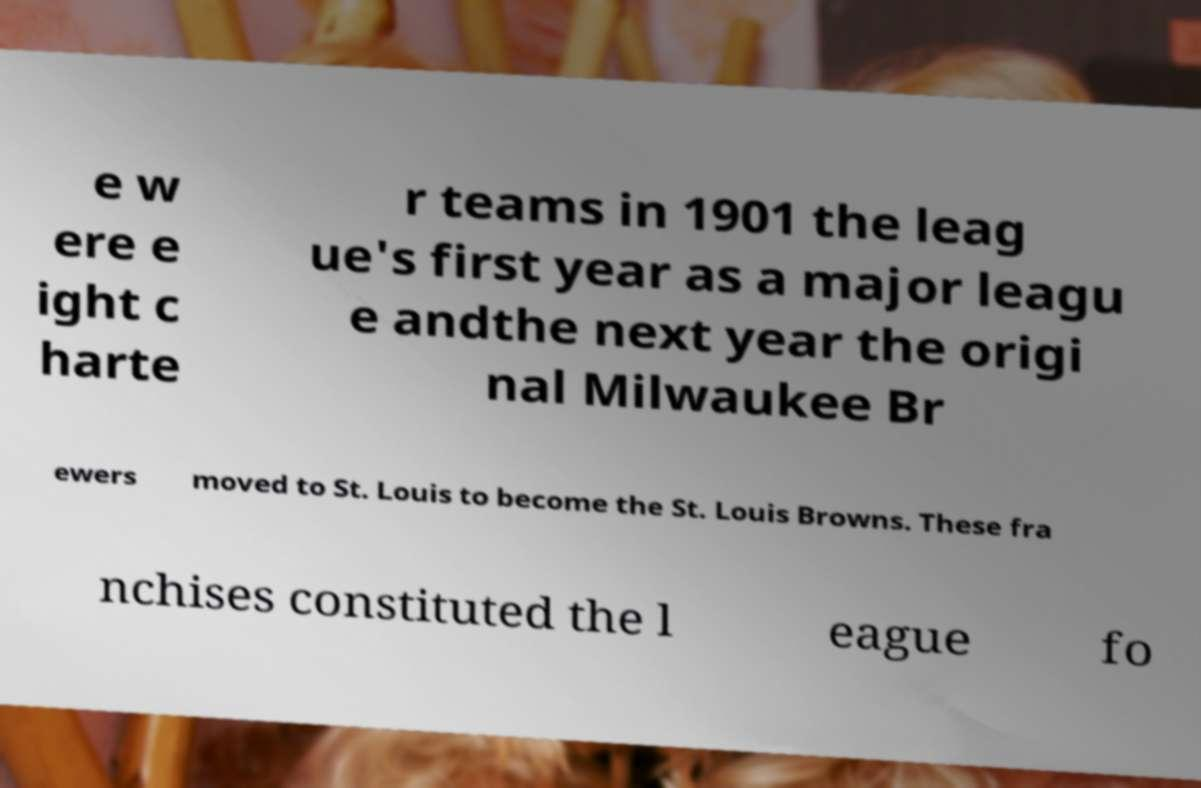Could you extract and type out the text from this image? e w ere e ight c harte r teams in 1901 the leag ue's first year as a major leagu e andthe next year the origi nal Milwaukee Br ewers moved to St. Louis to become the St. Louis Browns. These fra nchises constituted the l eague fo 